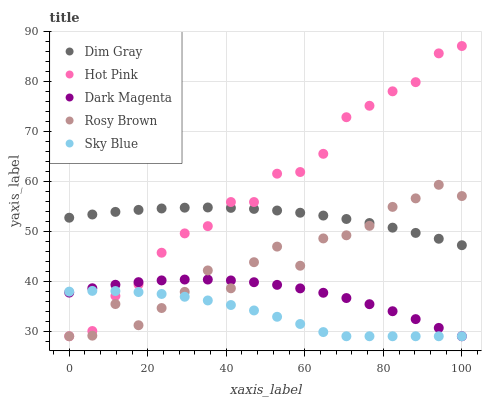Does Sky Blue have the minimum area under the curve?
Answer yes or no. Yes. Does Hot Pink have the maximum area under the curve?
Answer yes or no. Yes. Does Rosy Brown have the minimum area under the curve?
Answer yes or no. No. Does Rosy Brown have the maximum area under the curve?
Answer yes or no. No. Is Dim Gray the smoothest?
Answer yes or no. Yes. Is Rosy Brown the roughest?
Answer yes or no. Yes. Is Rosy Brown the smoothest?
Answer yes or no. No. Is Dim Gray the roughest?
Answer yes or no. No. Does Sky Blue have the lowest value?
Answer yes or no. Yes. Does Dim Gray have the lowest value?
Answer yes or no. No. Does Hot Pink have the highest value?
Answer yes or no. Yes. Does Rosy Brown have the highest value?
Answer yes or no. No. Is Dark Magenta less than Dim Gray?
Answer yes or no. Yes. Is Dim Gray greater than Dark Magenta?
Answer yes or no. Yes. Does Hot Pink intersect Rosy Brown?
Answer yes or no. Yes. Is Hot Pink less than Rosy Brown?
Answer yes or no. No. Is Hot Pink greater than Rosy Brown?
Answer yes or no. No. Does Dark Magenta intersect Dim Gray?
Answer yes or no. No. 